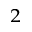<formula> <loc_0><loc_0><loc_500><loc_500>_ { 2 }</formula> 